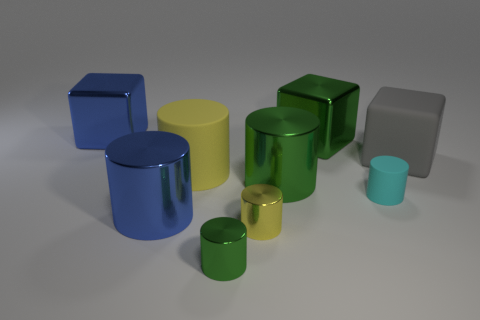Is the shape of the gray rubber thing the same as the matte thing that is in front of the big yellow rubber object?
Give a very brief answer. No. What size is the shiny object that is the same color as the large rubber cylinder?
Keep it short and to the point. Small. How many things are small purple spheres or cylinders?
Make the answer very short. 6. The big blue shiny thing behind the matte cylinder in front of the big green cylinder is what shape?
Your response must be concise. Cube. Do the large green metal object that is in front of the gray rubber cube and the cyan thing have the same shape?
Give a very brief answer. Yes. There is a gray block that is made of the same material as the large yellow thing; what is its size?
Your answer should be compact. Large. What number of things are big metallic cylinders that are behind the large blue metallic cylinder or shiny cylinders behind the large blue cylinder?
Provide a succinct answer. 1. Are there an equal number of things that are to the right of the big blue metallic cylinder and small yellow cylinders that are behind the gray matte cube?
Keep it short and to the point. No. The big matte thing that is on the left side of the gray rubber block is what color?
Your response must be concise. Yellow. There is a small matte cylinder; is it the same color as the large metallic cube that is left of the yellow metallic thing?
Your response must be concise. No. 